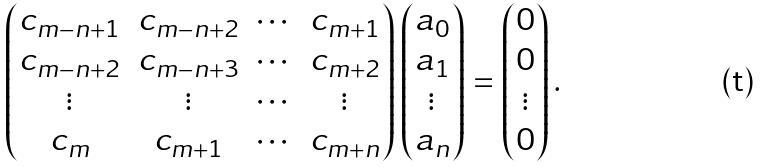Convert formula to latex. <formula><loc_0><loc_0><loc_500><loc_500>\begin{pmatrix} c _ { m - n + 1 } & c _ { m - n + 2 } & \cdots & c _ { m + 1 } \\ c _ { m - n + 2 } & c _ { m - n + 3 } & \cdots & c _ { m + 2 } \\ \vdots & \vdots & \cdots & \vdots \\ c _ { m } & c _ { m + 1 } & \cdots & c _ { m + n } \end{pmatrix} \begin{pmatrix} a _ { 0 } \\ a _ { 1 } \\ \vdots \\ a _ { n } \end{pmatrix} = \begin{pmatrix} 0 \\ 0 \\ \vdots \\ 0 \end{pmatrix} .</formula> 